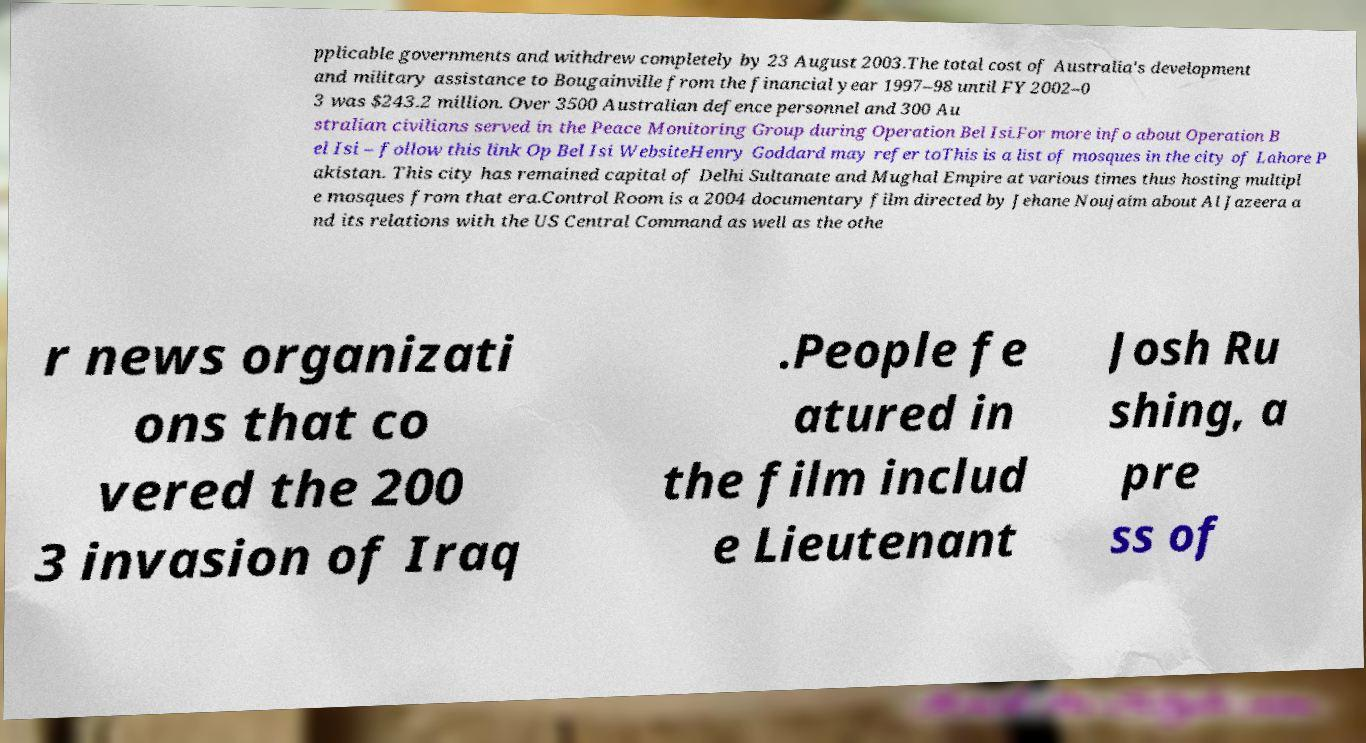Please identify and transcribe the text found in this image. pplicable governments and withdrew completely by 23 August 2003.The total cost of Australia's development and military assistance to Bougainville from the financial year 1997–98 until FY 2002–0 3 was $243.2 million. Over 3500 Australian defence personnel and 300 Au stralian civilians served in the Peace Monitoring Group during Operation Bel Isi.For more info about Operation B el Isi – follow this link Op Bel Isi WebsiteHenry Goddard may refer toThis is a list of mosques in the city of Lahore P akistan. This city has remained capital of Delhi Sultanate and Mughal Empire at various times thus hosting multipl e mosques from that era.Control Room is a 2004 documentary film directed by Jehane Noujaim about Al Jazeera a nd its relations with the US Central Command as well as the othe r news organizati ons that co vered the 200 3 invasion of Iraq .People fe atured in the film includ e Lieutenant Josh Ru shing, a pre ss of 